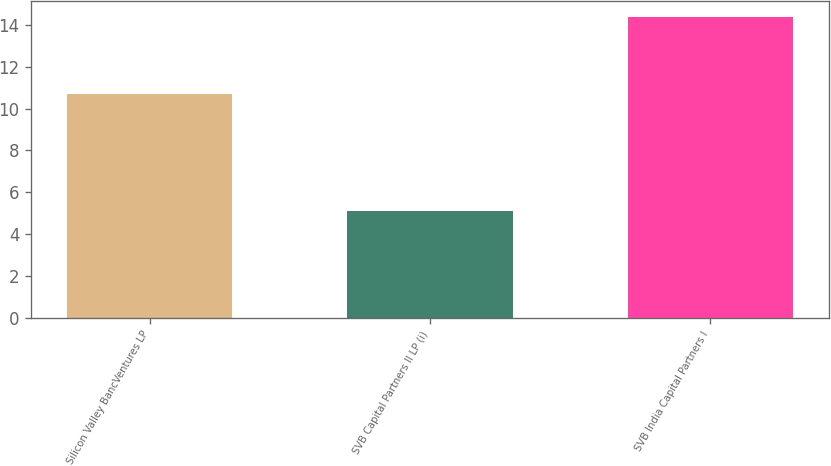Convert chart to OTSL. <chart><loc_0><loc_0><loc_500><loc_500><bar_chart><fcel>Silicon Valley BancVentures LP<fcel>SVB Capital Partners II LP (i)<fcel>SVB India Capital Partners I<nl><fcel>10.7<fcel>5.1<fcel>14.4<nl></chart> 